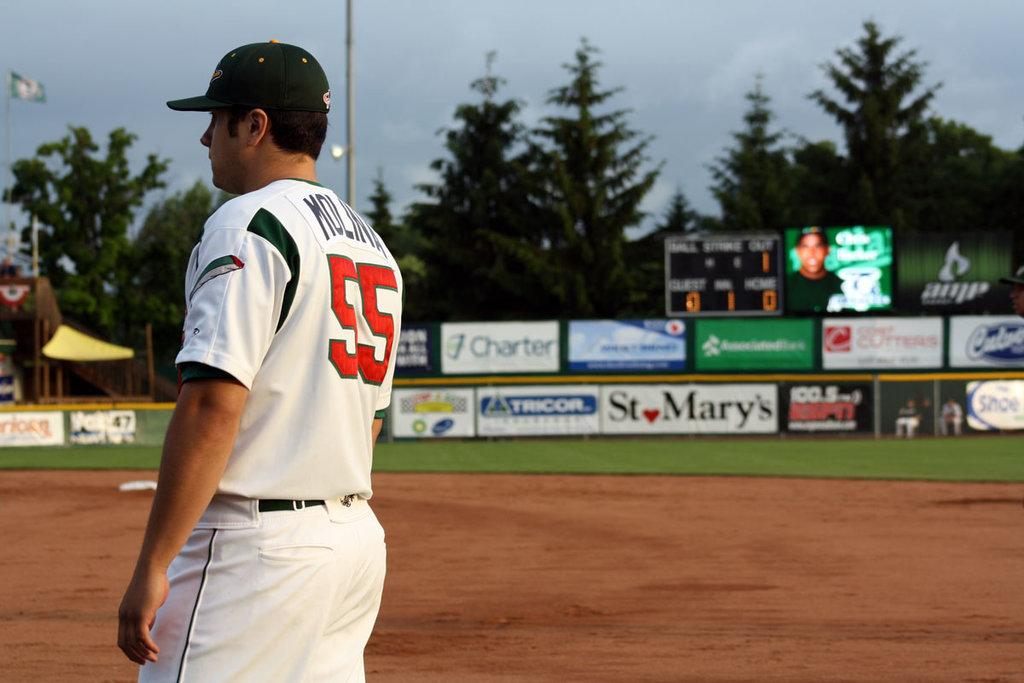<image>
Give a short and clear explanation of the subsequent image. a boy playing baseball with the number 55 on his back 